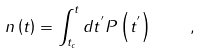<formula> <loc_0><loc_0><loc_500><loc_500>n \left ( t \right ) = \int _ { t _ { c } } ^ { t } d t ^ { ^ { \prime } } P \left ( t ^ { ^ { \prime } } \right ) \quad ,</formula> 